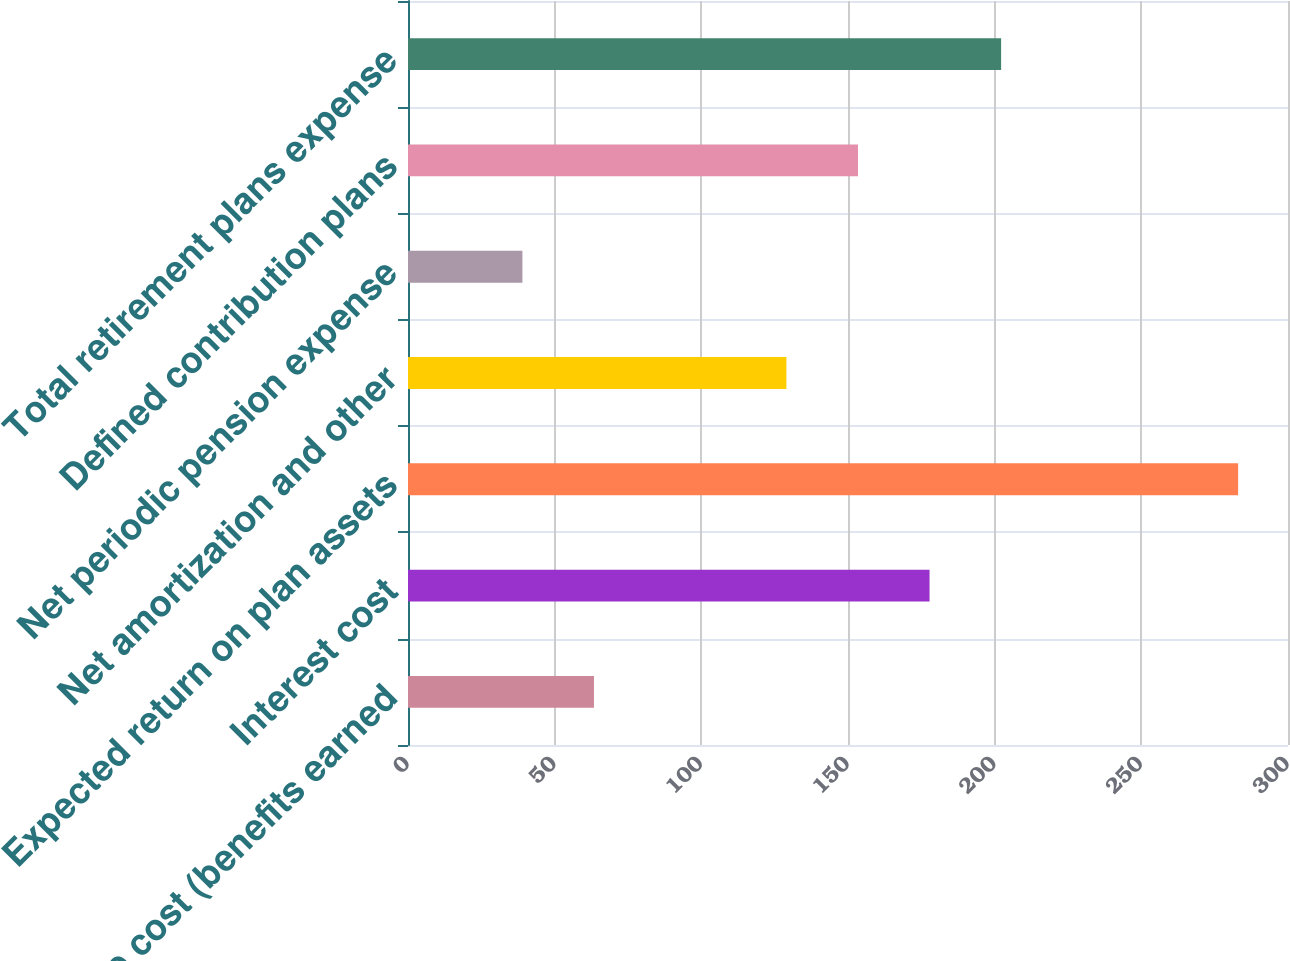<chart> <loc_0><loc_0><loc_500><loc_500><bar_chart><fcel>Service cost (benefits earned<fcel>Interest cost<fcel>Expected return on plan assets<fcel>Net amortization and other<fcel>Net periodic pension expense<fcel>Defined contribution plans<fcel>Total retirement plans expense<nl><fcel>63.4<fcel>177.8<fcel>283<fcel>129<fcel>39<fcel>153.4<fcel>202.2<nl></chart> 